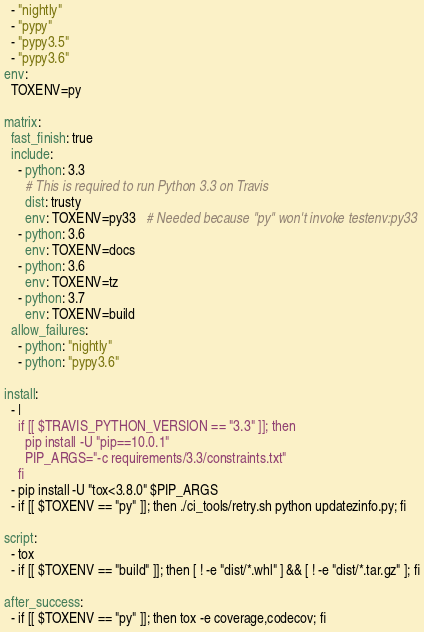Convert code to text. <code><loc_0><loc_0><loc_500><loc_500><_YAML_>  - "nightly"
  - "pypy"
  - "pypy3.5"
  - "pypy3.6"
env:
  TOXENV=py

matrix:
  fast_finish: true
  include:
    - python: 3.3
      # This is required to run Python 3.3 on Travis
      dist: trusty
      env: TOXENV=py33   # Needed because "py" won't invoke testenv:py33
    - python: 3.6
      env: TOXENV=docs
    - python: 3.6
      env: TOXENV=tz
    - python: 3.7
      env: TOXENV=build
  allow_failures:
    - python: "nightly"
    - python: "pypy3.6"

install:
  - |
    if [[ $TRAVIS_PYTHON_VERSION == "3.3" ]]; then
      pip install -U "pip==10.0.1"
      PIP_ARGS="-c requirements/3.3/constraints.txt"
    fi
  - pip install -U "tox<3.8.0" $PIP_ARGS
  - if [[ $TOXENV == "py" ]]; then ./ci_tools/retry.sh python updatezinfo.py; fi

script:
  - tox
  - if [[ $TOXENV == "build" ]]; then [ ! -e "dist/*.whl" ] && [ ! -e "dist/*.tar.gz" ]; fi

after_success:
  - if [[ $TOXENV == "py" ]]; then tox -e coverage,codecov; fi
</code> 